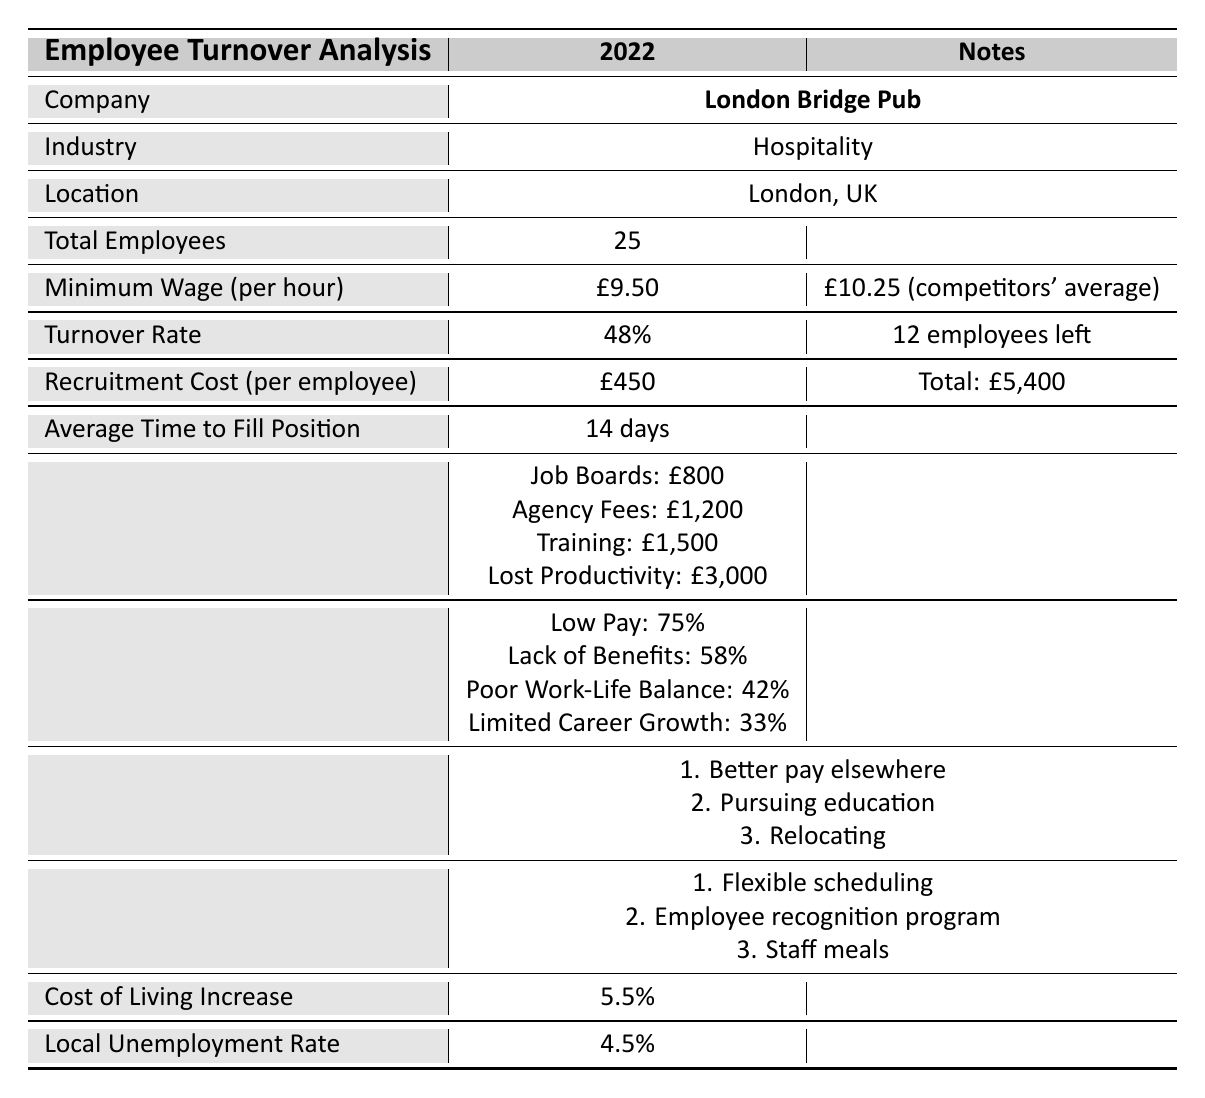What is the turnover rate for the London Bridge Pub? The turnover rate for the London Bridge Pub is listed in the table as 48%.
Answer: 48% How much did it cost to recruit a single employee? The recruitment cost per employee is stated as £450 in the table.
Answer: £450 What are the total recruitment expenses for the year? The total recruitment cost is mentioned as £5,400 in the table.
Answer: £5,400 How many employees left the company in 2022? The table indicates that 12 employees left the company during the year.
Answer: 12 What was the average time taken to fill a position? The table specifies an average time of 14 days to fill a position.
Answer: 14 days What percentage of employees cited low pay as a reason for leaving? According to the exit interview findings, 75% of employees cited low pay as a reason for leaving.
Answer: 75% What is the local unemployment rate in the area? The local unemployment rate provided in the table is 4.5%.
Answer: 4.5% How much was spent on job board expenses? The table shows that the expenses on job boards amounted to £800.
Answer: £800 What are the top three reasons for leaving according to the data? The top three reasons for leaving are: 1) Better pay elsewhere, 2) Pursuing education, 3) Relocating.
Answer: Better pay elsewhere, pursuing education, relocating If the minimum wage is £9.50, how much higher is the competitors' average wage? The competitors' average wage is £10.25. Thus, the difference is £10.25 - £9.50 = £0.75 higher.
Answer: £0.75 What is the total cost incurred due to lost productivity? The table lists the lost productivity cost as £3,000.
Answer: £3,000 How does the turnover rate at the London Bridge Pub compare to the local unemployment rate? The turnover rate is 48% while the local unemployment rate is 4.5%, indicating a significantly higher turnover rate than the local unemployment rate.
Answer: Higher than local unemployment What is the total cost of the recruitment expenses calculated from job board expenses, agency fees, training costs, and lost productivity? Adding the individual recruitment expenses gives: £800 + £1200 + £1500 + £3000 = £5500. Therefore, total recruitment expenses equal £5,500.
Answer: £5,500 What retention initiatives are being implemented at the London Bridge Pub? The retention initiatives listed are: 1) Flexible scheduling, 2) Employee recognition program, 3) Staff meals.
Answer: Flexible scheduling, employee recognition program, staff meals What fraction of exit interview respondents mentioned limited career growth as a reason for leaving? The table shows that 33% mentioned limited career growth; to express this as a fraction, it can be approximated as 1/3.
Answer: 1/3 If the cost of living increases by 5.5%, how might that affect the current minimum wage? The potential effect would be that employees may demand higher wages, increasing overall labor costs; however, the exact new wage would depend on negotiations.
Answer: Potentially higher demands for wages 